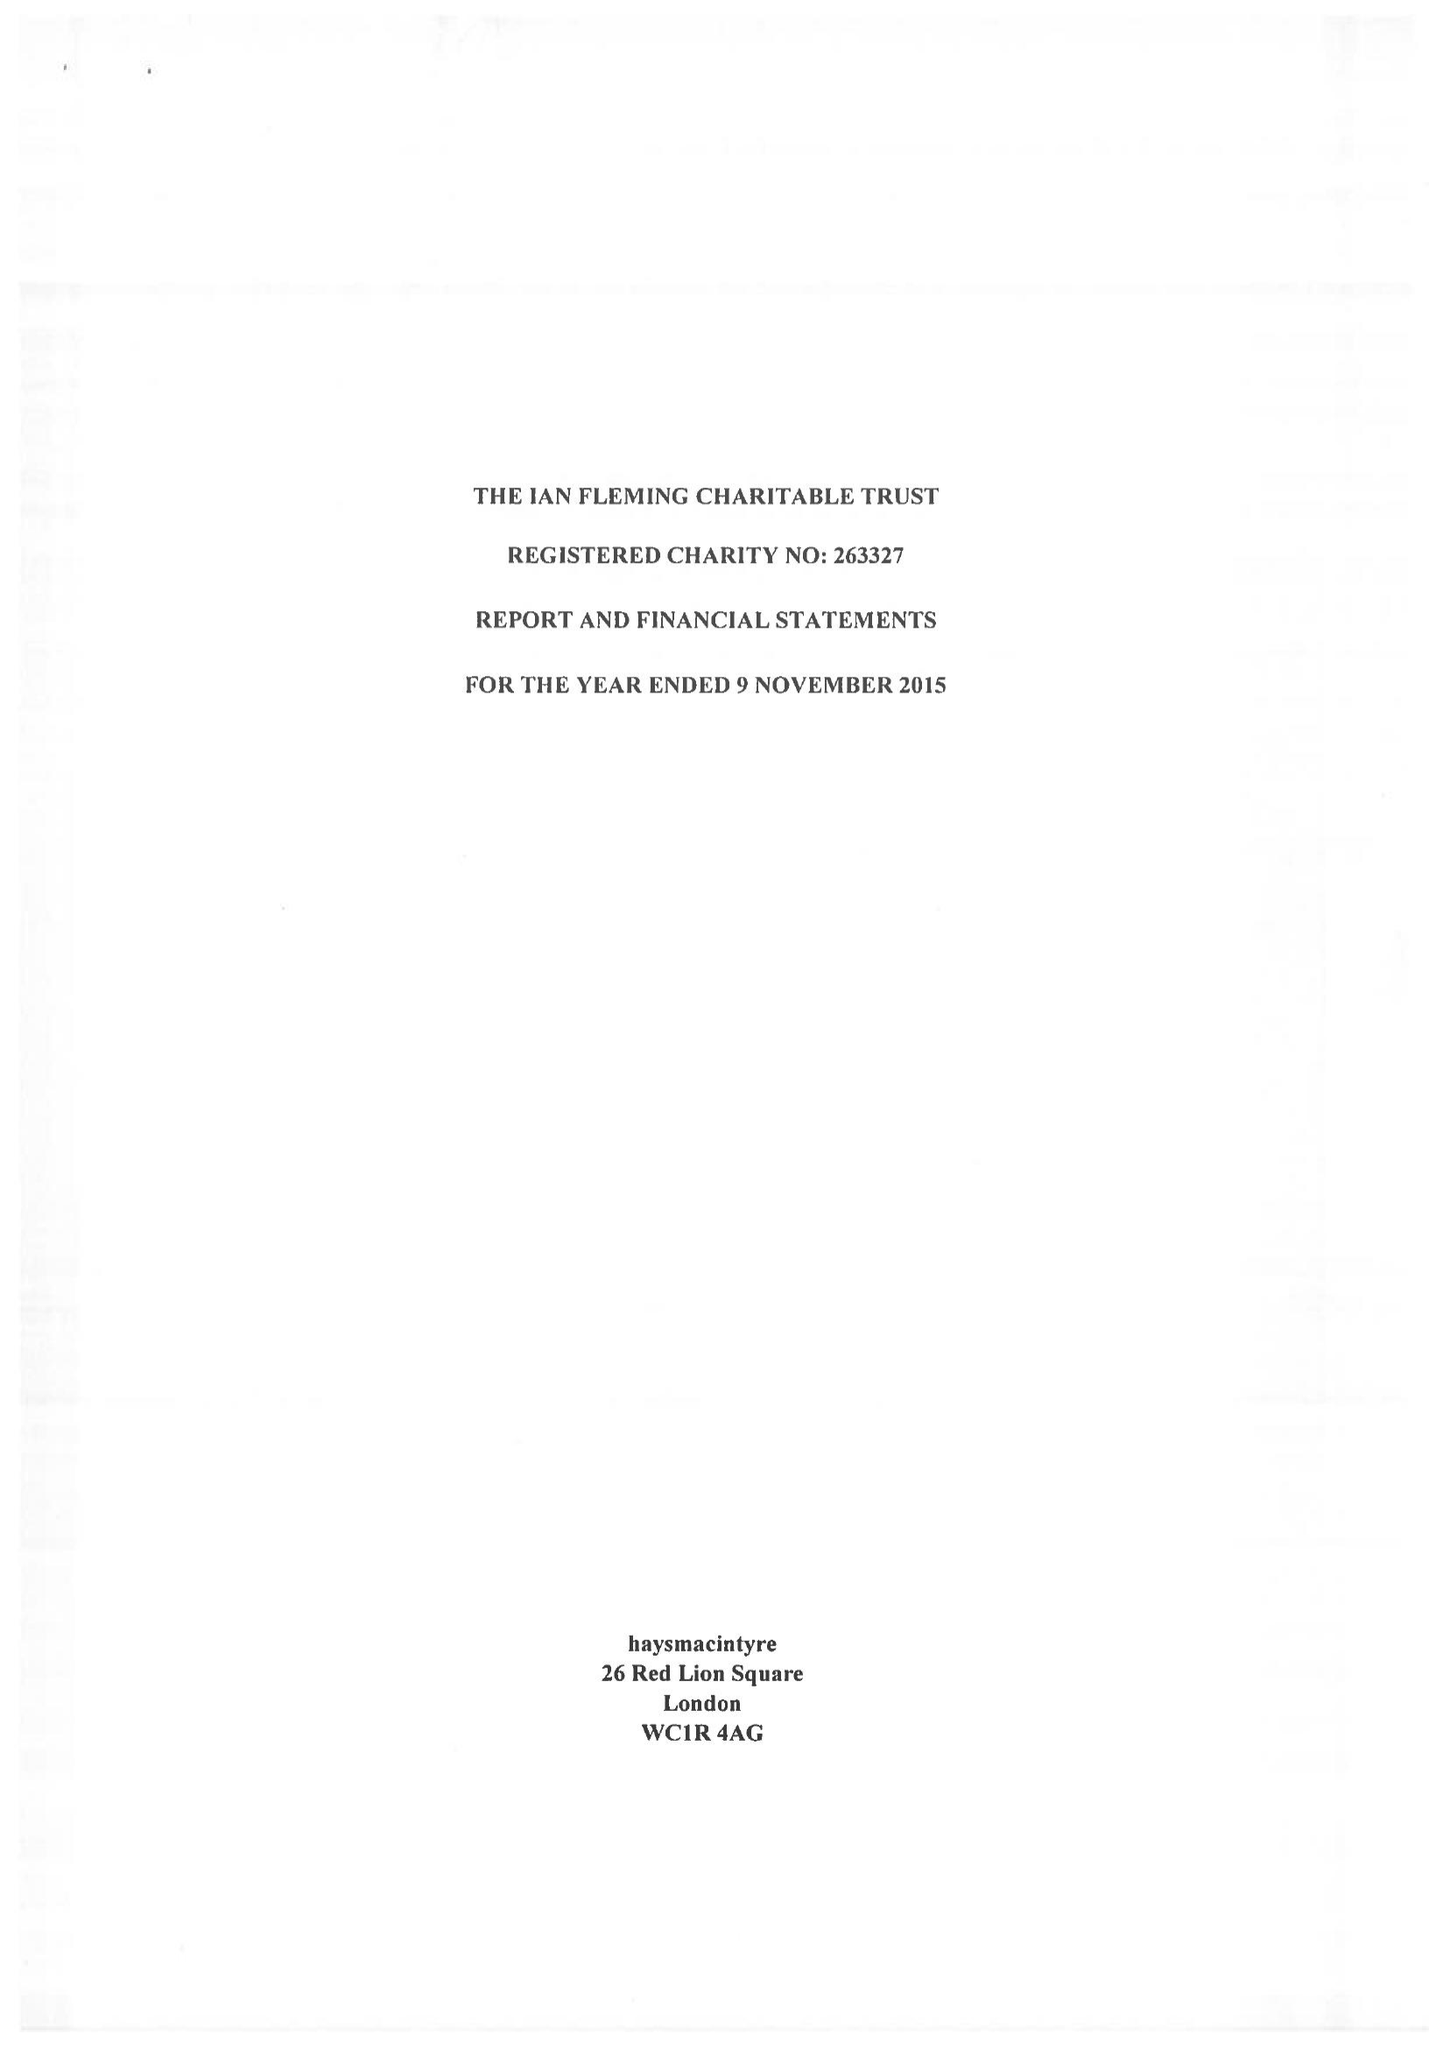What is the value for the charity_name?
Answer the question using a single word or phrase. The Ian Fleming Charitable Trust 